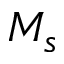Convert formula to latex. <formula><loc_0><loc_0><loc_500><loc_500>M _ { s }</formula> 